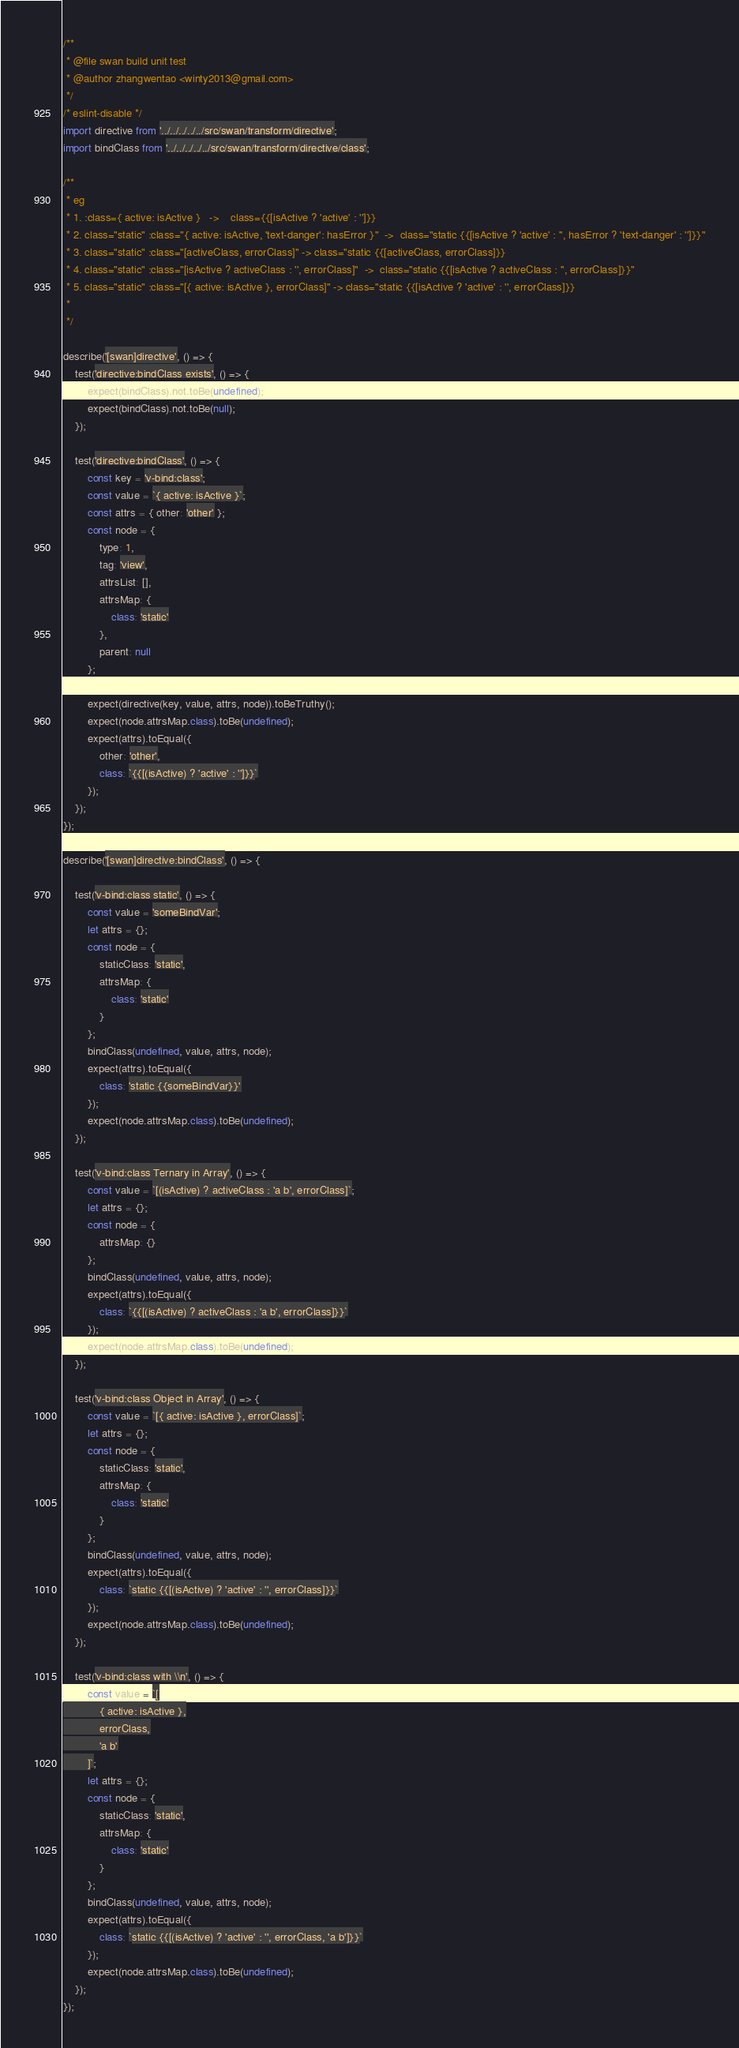<code> <loc_0><loc_0><loc_500><loc_500><_JavaScript_>
/**
 * @file swan build unit test
 * @author zhangwentao <winty2013@gmail.com>
 */
/* eslint-disable */
import directive from '../../../../../src/swan/transform/directive';
import bindClass from '../../../../../src/swan/transform/directive/class';

/**
 * eg
 * 1. :class={ active: isActive }   ->    class={{[isActive ? 'active' : '']}}
 * 2. class="static" :class="{ active: isActive, 'text-danger': hasError }"  ->  class="static {{[isActive ? 'active' : '', hasError ? 'text-danger' : '']}}"
 * 3. class="static" :class="[activeClass, errorClass]" -> class="static {{[activeClass, errorClass]}}
 * 4. class="static" :class="[isActive ? activeClass : '', errorClass]"  ->  class="static {{[isActive ? activeClass : '', errorClass]}}"
 * 5. class="static" :class="[{ active: isActive }, errorClass]" -> class="static {{[isActive ? 'active' : '', errorClass]}}
 *
 */

describe('[swan]directive', () => {
    test('directive:bindClass exists', () => {
        expect(bindClass).not.toBe(undefined);
        expect(bindClass).not.toBe(null);
    });

    test('directive:bindClass', () => {
        const key = 'v-bind:class';
        const value = `{ active: isActive }`;
        const attrs = { other: 'other' };
        const node = {
            type: 1,
            tag: 'view',
            attrsList: [],
            attrsMap: { 
                class: 'static'
            },
            parent: null
        };

        expect(directive(key, value, attrs, node)).toBeTruthy();
        expect(node.attrsMap.class).toBe(undefined);
        expect(attrs).toEqual({
            other: 'other',
            class: `{{[(isActive) ? 'active' : '']}}`
        });
    });
});

describe('[swan]directive:bindClass', () => {

    test('v-bind:class static', () => {
        const value = 'someBindVar';
        let attrs = {};
        const node = {
            staticClass: 'static',
            attrsMap: { 
                class: 'static'
            }
        };
        bindClass(undefined, value, attrs, node);
        expect(attrs).toEqual({ 
            class: 'static {{someBindVar}}'
        });
        expect(node.attrsMap.class).toBe(undefined);
    });

    test('v-bind:class Ternary in Array', () => {
        const value = `[(isActive) ? activeClass : 'a b', errorClass]`;
        let attrs = {};
        const node = {
            attrsMap: {}
        };
        bindClass(undefined, value, attrs, node);
        expect(attrs).toEqual({ 
            class: `{{[(isActive) ? activeClass : 'a b', errorClass]}}`
        });
        expect(node.attrsMap.class).toBe(undefined);
    });

    test('v-bind:class Object in Array', () => {
        const value = `[{ active: isActive }, errorClass]`;
        let attrs = {};
        const node = {
            staticClass: 'static',
            attrsMap: { 
                class: 'static'
            }
        };
        bindClass(undefined, value, attrs, node);
        expect(attrs).toEqual({ 
            class: `static {{[(isActive) ? 'active' : '', errorClass]}}`
        });
        expect(node.attrsMap.class).toBe(undefined);
    });

    test('v-bind:class with \\n', () => {
        const value = `[
            { active: isActive },
            errorClass,
            'a b'
        ]`;
        let attrs = {};
        const node = {
            staticClass: 'static',
            attrsMap: { 
                class: 'static'
            }
        };
        bindClass(undefined, value, attrs, node);
        expect(attrs).toEqual({ 
            class: `static {{[(isActive) ? 'active' : '', errorClass, 'a b']}}`
        });
        expect(node.attrsMap.class).toBe(undefined);
    });
});</code> 